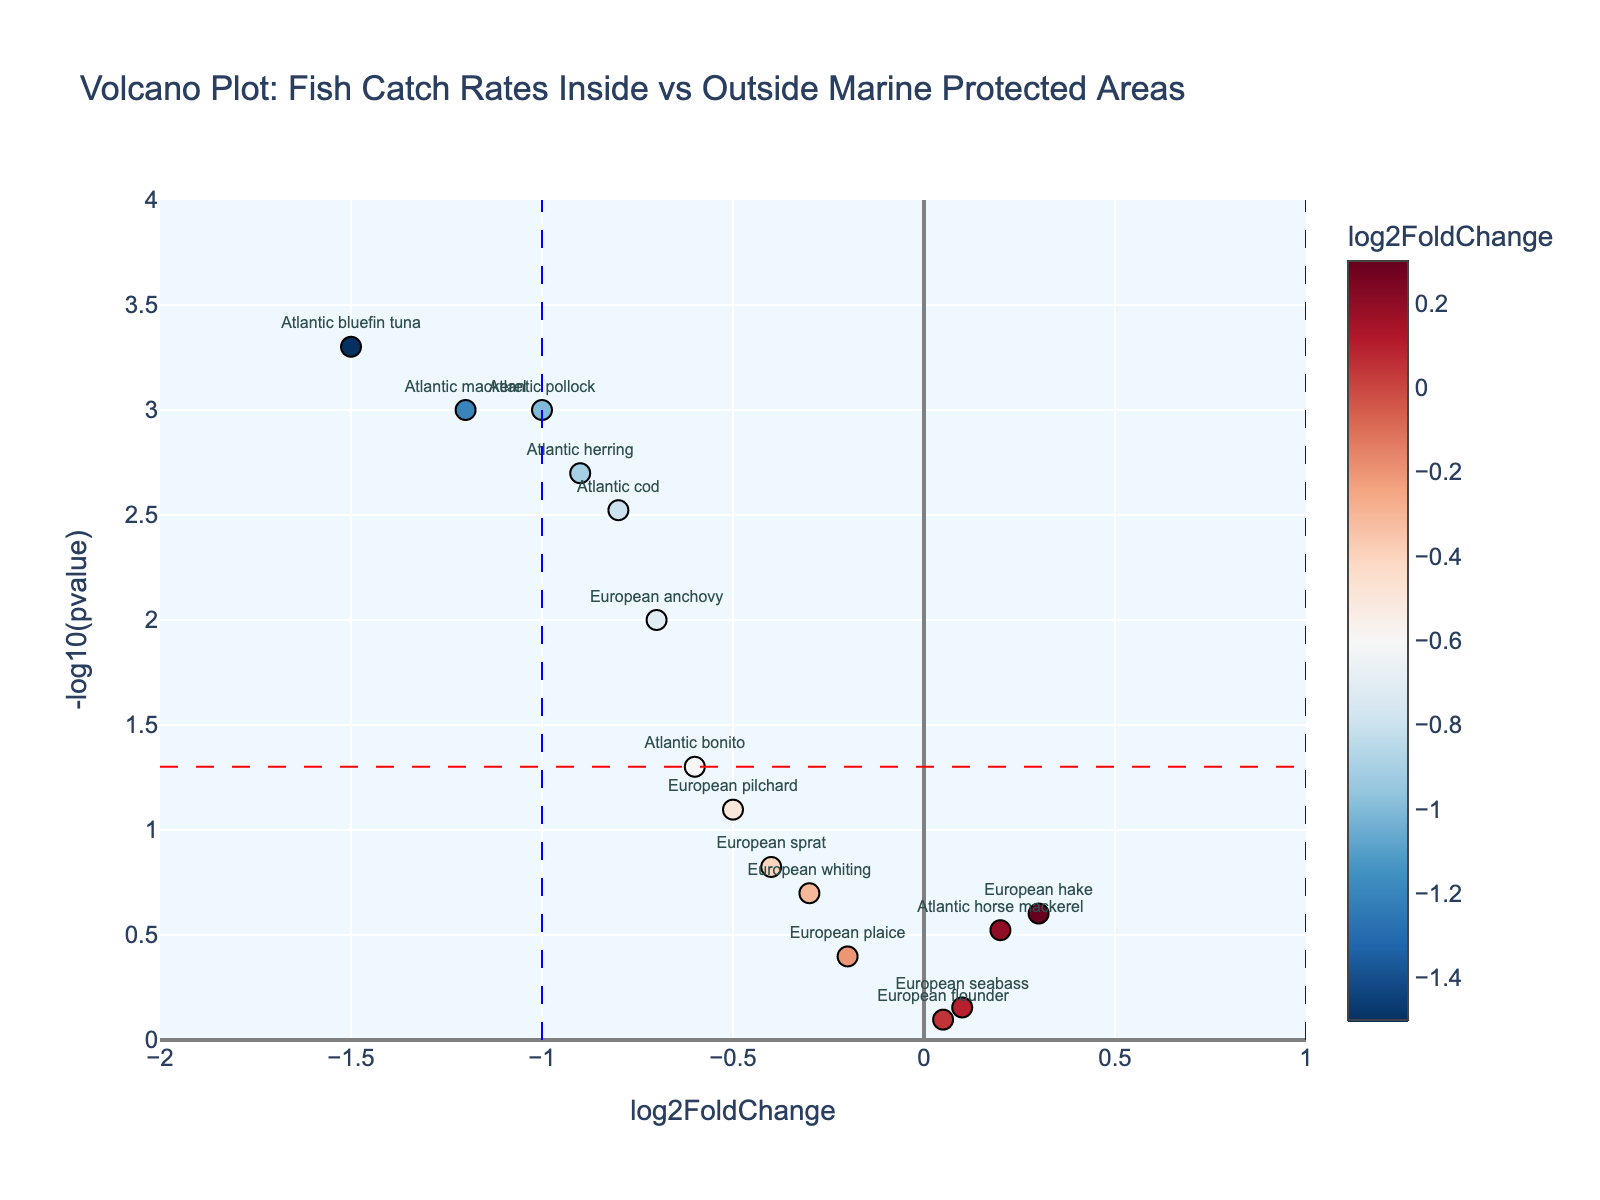What's the title of the figure? The title is usually placed at the top of the figure and summarises the main topic of the plot. According to the given code, the title of the figure is "Volcano Plot: Fish Catch Rates Inside vs Outside Marine Protected Areas".
Answer: Volcano Plot: Fish Catch Rates Inside vs Outside Marine Protected Areas What do the x-axis and y-axis represent? The labels of the axes indicate what each axis represents. The x-axis represents "log2FoldChange" and the y-axis represents "-log10(pvalue)".
Answer: log2FoldChange and -log10(pvalue) How many species have a p-value less than 0.05? To find this, observe the y-axis and count the number of points that lie above the horizontal red dashed line which represents -log10(0.05). Based on the provided data, these species are Atlantic cod, Atlantic mackerel, Atlantic herring, Atlantic bluefin tuna, European anchovy, and Atlantic pollock.
Answer: 6 species Which species has the highest -log10(pvalue)? The species with the highest -log10(pvalue) will be the point that is at the top of the y-axis. From the data, Atlantic bluefin tuna has the lowest p-value (0.0005), hence the highest -log10(pvalue).
Answer: Atlantic bluefin tuna Which species has the lowest log2FoldChange? The species with the lowest log2FoldChange will be the point farthest to the left on the x-axis. According to the data, Atlantic bluefin tuna has the lowest log2FoldChange of -1.5.
Answer: Atlantic bluefin tuna How many species have a log2FoldChange less than -1 and a p-value less than 0.05? Look for points that are to the left of the vertical blue dashed line at x = -1 and are also above the horizontal red dashed line. From the data, these species are Atlantic mackerel, Atlantic bluefin tuna, and Atlantic pollock.
Answer: 3 species Do any species have a positive log2FoldChange and p-value less than 0.05? Positive log2FoldChange values are to the right of the vertical blue dashed line at x = 0. We need to check if any of these points are also above the horizontal red dashed line at -log10(0.05). From the data, no species meet both criteria.
Answer: No Which species have log2FoldChange values between -0.5 and 0.5? Look for the points within the range of -0.5 to 0.5 on the x-axis. From the data, these species are European hake (0.3), European pilchard (-0.5), European seabass (0.1), European plaice (-0.2), European sprat (-0.4), Atlantic horse mackerel (0.2), European whiting (-0.3), and European flounder (0.05).
Answer: European hake, European pilchard, European seabass, European plaice, European sprat, Atlantic horse mackerel, European whiting, European flounder Which species are closest to the origin (0,0)? To find the species closest to the origin, we need to calculate the Euclidean distance (sqrt((x-0)^2 + (y-0)^2)) for each point. European flounder with coordinates (0.05, 0.097) is closest to the origin.
Answer: European flounder 